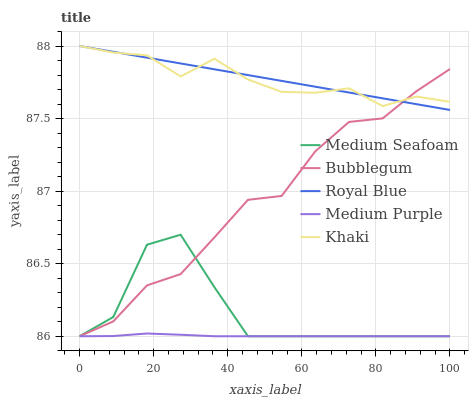Does Medium Purple have the minimum area under the curve?
Answer yes or no. Yes. Does Royal Blue have the maximum area under the curve?
Answer yes or no. Yes. Does Khaki have the minimum area under the curve?
Answer yes or no. No. Does Khaki have the maximum area under the curve?
Answer yes or no. No. Is Royal Blue the smoothest?
Answer yes or no. Yes. Is Medium Seafoam the roughest?
Answer yes or no. Yes. Is Khaki the smoothest?
Answer yes or no. No. Is Khaki the roughest?
Answer yes or no. No. Does Medium Purple have the lowest value?
Answer yes or no. Yes. Does Royal Blue have the lowest value?
Answer yes or no. No. Does Khaki have the highest value?
Answer yes or no. Yes. Does Medium Seafoam have the highest value?
Answer yes or no. No. Is Medium Purple less than Royal Blue?
Answer yes or no. Yes. Is Royal Blue greater than Medium Seafoam?
Answer yes or no. Yes. Does Khaki intersect Royal Blue?
Answer yes or no. Yes. Is Khaki less than Royal Blue?
Answer yes or no. No. Is Khaki greater than Royal Blue?
Answer yes or no. No. Does Medium Purple intersect Royal Blue?
Answer yes or no. No. 